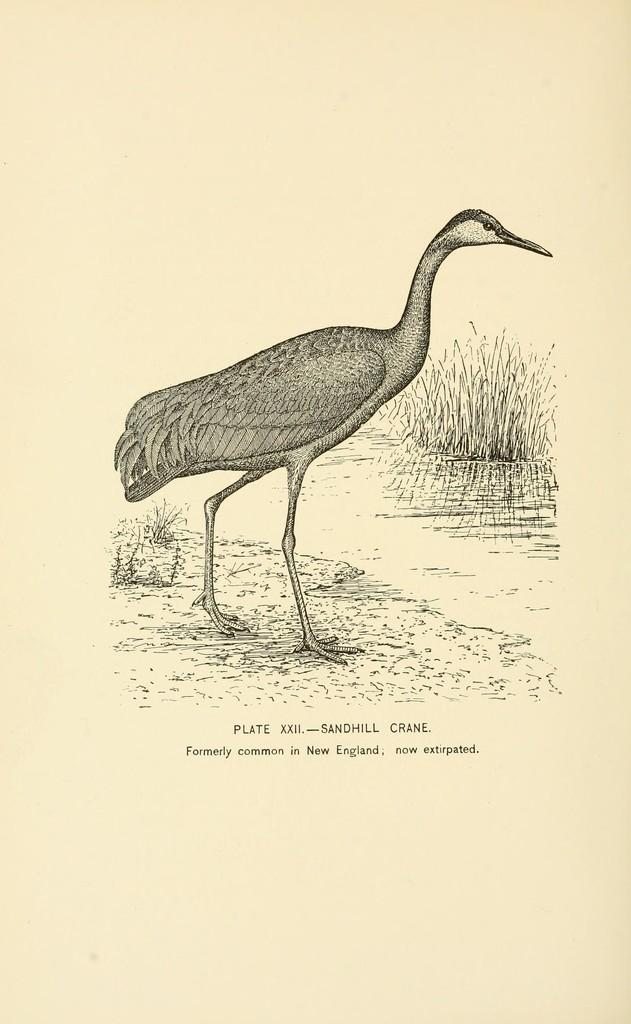What is the main subject of the image? There is a crane in the image. Where is the crane located? The crane is standing on the ground. What type of vegetation is visible in front of the crane? There is grass in front of the crane. Is there any text or markings on the crane? Yes, there is writing on the crane. What type of yak can be seen singing a song to the crane in the image? There is no yak or song present in the image; it features a crane standing on the ground with grass in front of it and writing on the crane. How many daughters does the crane have in the image? There are no daughters mentioned or depicted in the image, as it features a crane standing on the ground with grass in front of it and writing on the crane. 